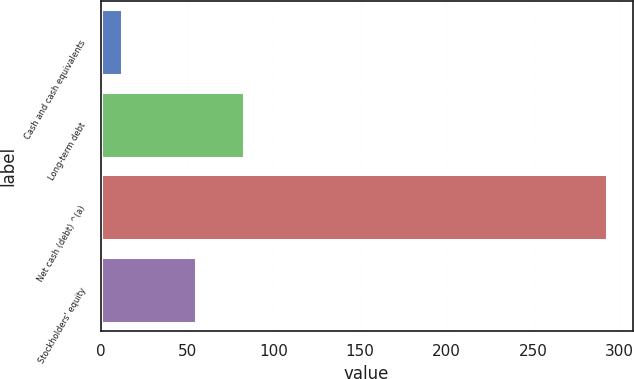Convert chart to OTSL. <chart><loc_0><loc_0><loc_500><loc_500><bar_chart><fcel>Cash and cash equivalents<fcel>Long-term debt<fcel>Net cash (debt) ^(a)<fcel>Stockholders' equity<nl><fcel>12.4<fcel>82.84<fcel>292.8<fcel>54.8<nl></chart> 